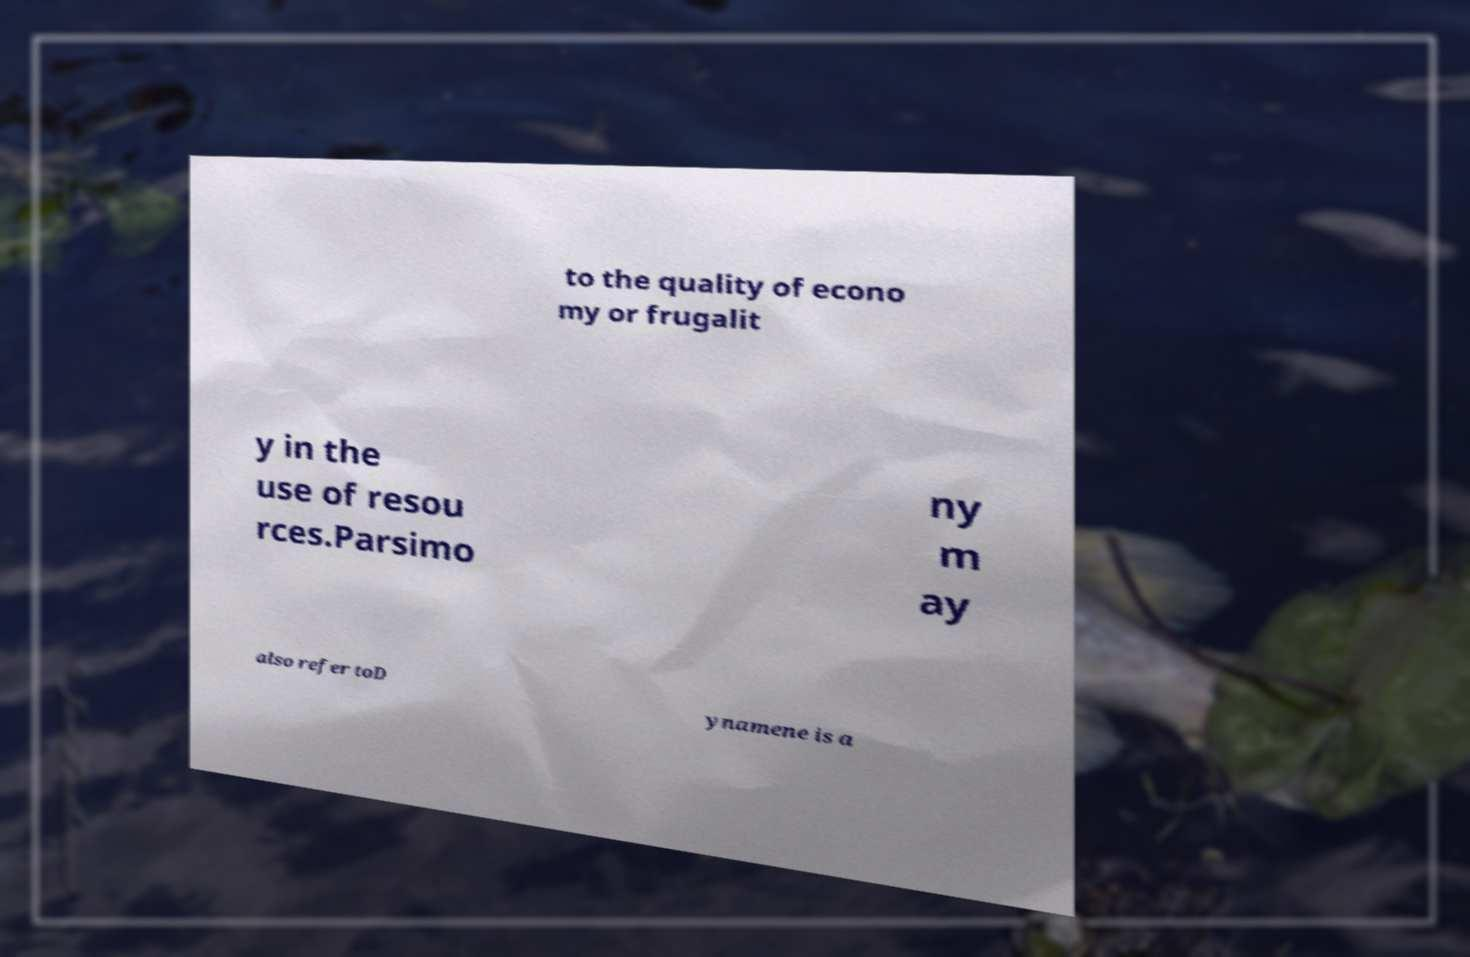Could you extract and type out the text from this image? to the quality of econo my or frugalit y in the use of resou rces.Parsimo ny m ay also refer toD ynamene is a 